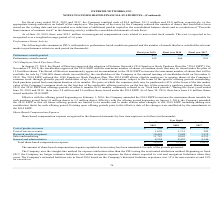From Extreme Networks's financial document, Which years does the table provide information for Share-based compensation expense recognized in the financial statements by line item caption? The document contains multiple relevant values: 2019, 2018, 2017. From the document: "For fiscal years ended 2019, 2018 and 2017, the Company remitted cash of $8.4 million, $11.3 million and $2.0 million, respectively, to the For fiscal..." Also, What was the cost of product revenue in 2017? According to the financial document, 333 (in thousands). The relevant text states: "Cost of product revenue $ 844 $ 564 $ 333..." Also, What was the amount of research and development in 2019? According to the financial document, 10,443 (in thousands). The relevant text states: "Research and development 10,443 7,642 3,312..." Also, How many years did Cost of service revenue exceed $1,000 thousand? Counting the relevant items in the document: 2019, 2018, I find 2 instances. The key data points involved are: 2018, 2019. Also, can you calculate: What was the change in cost of product revenue between 2018 and 2019? Based on the calculation: 844-564, the result is 280 (in thousands). This is based on the information: "Cost of product revenue $ 844 $ 564 $ 333 Cost of product revenue $ 844 $ 564 $ 333..." The key data points involved are: 564, 844. Also, can you calculate: What was the percentage change in Sales and marketing between 2017 and 2018? To answer this question, I need to perform calculations using the financial data. The calculation is: (9,843-4,253)/4,253, which equals 131.44 (percentage). This is based on the information: "Sales and marketing 11,747 9,843 4,253 Sales and marketing 11,747 9,843 4,253..." The key data points involved are: 4,253, 9,843. 